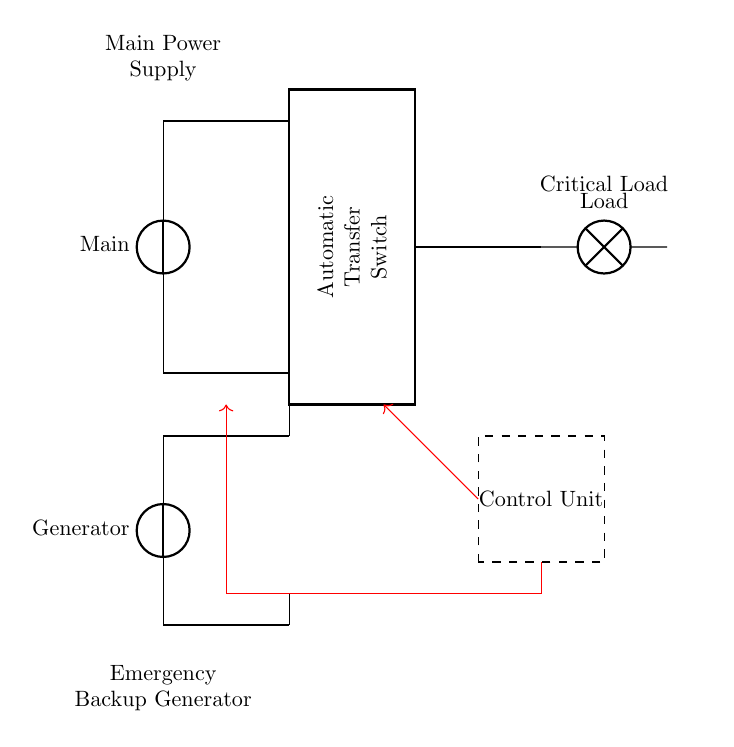What is the main power supply in this circuit? The main power supply is provided by the voltage source depicted at the top left of the circuit diagram, labeled as "Main."
Answer: Main What is the function of the Automatic Transfer Switch? The Automatic Transfer Switch is responsible for switching the power supply from the main source to the generator automatically when a power outage occurs. This function is crucial to ensure that critical loads remain powered without manual intervention.
Answer: Switching power supply How many voltage sources are present in the circuit? There are two voltage sources in the circuit: one labeled "Main" and the other labeled "Generator." They are illustrated as distinct sources on the diagram.
Answer: Two What does the control unit do in this emergency generator circuit? The control unit manages the operation of the Automatic Transfer Switch by sensing the status of the main power and sending control signals accordingly. It ensures a seamless shift from the primary to the backup power source without interruption.
Answer: Manages operations Which component is responsible for supplying power to the load when the main power is unavailable? The generator is responsible for supplying power to the load when the main power is down, as indicated by its connection to the Automatic Transfer Switch in the circuit diagram.
Answer: Generator Where is the critical load in this circuit? The critical load is located at the right side of the circuit, represented by a lamp labeled "Load." It receives power from the Automatic Transfer Switch depending on the status of the main or generator supply.
Answer: Lamp 